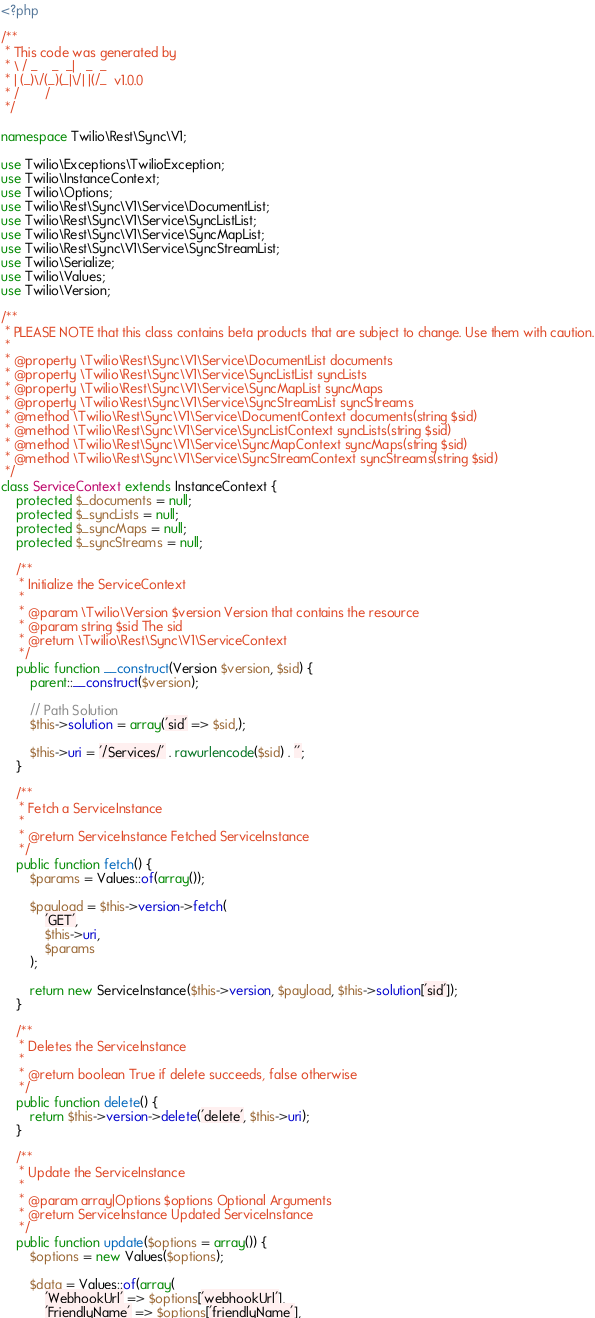<code> <loc_0><loc_0><loc_500><loc_500><_PHP_><?php

/**
 * This code was generated by
 * \ / _    _  _|   _  _
 * | (_)\/(_)(_|\/| |(/_  v1.0.0
 * /       /
 */

namespace Twilio\Rest\Sync\V1;

use Twilio\Exceptions\TwilioException;
use Twilio\InstanceContext;
use Twilio\Options;
use Twilio\Rest\Sync\V1\Service\DocumentList;
use Twilio\Rest\Sync\V1\Service\SyncListList;
use Twilio\Rest\Sync\V1\Service\SyncMapList;
use Twilio\Rest\Sync\V1\Service\SyncStreamList;
use Twilio\Serialize;
use Twilio\Values;
use Twilio\Version;

/**
 * PLEASE NOTE that this class contains beta products that are subject to change. Use them with caution.
 * 
 * @property \Twilio\Rest\Sync\V1\Service\DocumentList documents
 * @property \Twilio\Rest\Sync\V1\Service\SyncListList syncLists
 * @property \Twilio\Rest\Sync\V1\Service\SyncMapList syncMaps
 * @property \Twilio\Rest\Sync\V1\Service\SyncStreamList syncStreams
 * @method \Twilio\Rest\Sync\V1\Service\DocumentContext documents(string $sid)
 * @method \Twilio\Rest\Sync\V1\Service\SyncListContext syncLists(string $sid)
 * @method \Twilio\Rest\Sync\V1\Service\SyncMapContext syncMaps(string $sid)
 * @method \Twilio\Rest\Sync\V1\Service\SyncStreamContext syncStreams(string $sid)
 */
class ServiceContext extends InstanceContext {
    protected $_documents = null;
    protected $_syncLists = null;
    protected $_syncMaps = null;
    protected $_syncStreams = null;

    /**
     * Initialize the ServiceContext
     * 
     * @param \Twilio\Version $version Version that contains the resource
     * @param string $sid The sid
     * @return \Twilio\Rest\Sync\V1\ServiceContext 
     */
    public function __construct(Version $version, $sid) {
        parent::__construct($version);

        // Path Solution
        $this->solution = array('sid' => $sid,);

        $this->uri = '/Services/' . rawurlencode($sid) . '';
    }

    /**
     * Fetch a ServiceInstance
     * 
     * @return ServiceInstance Fetched ServiceInstance
     */
    public function fetch() {
        $params = Values::of(array());

        $payload = $this->version->fetch(
            'GET',
            $this->uri,
            $params
        );

        return new ServiceInstance($this->version, $payload, $this->solution['sid']);
    }

    /**
     * Deletes the ServiceInstance
     * 
     * @return boolean True if delete succeeds, false otherwise
     */
    public function delete() {
        return $this->version->delete('delete', $this->uri);
    }

    /**
     * Update the ServiceInstance
     * 
     * @param array|Options $options Optional Arguments
     * @return ServiceInstance Updated ServiceInstance
     */
    public function update($options = array()) {
        $options = new Values($options);

        $data = Values::of(array(
            'WebhookUrl' => $options['webhookUrl'],
            'FriendlyName' => $options['friendlyName'],</code> 